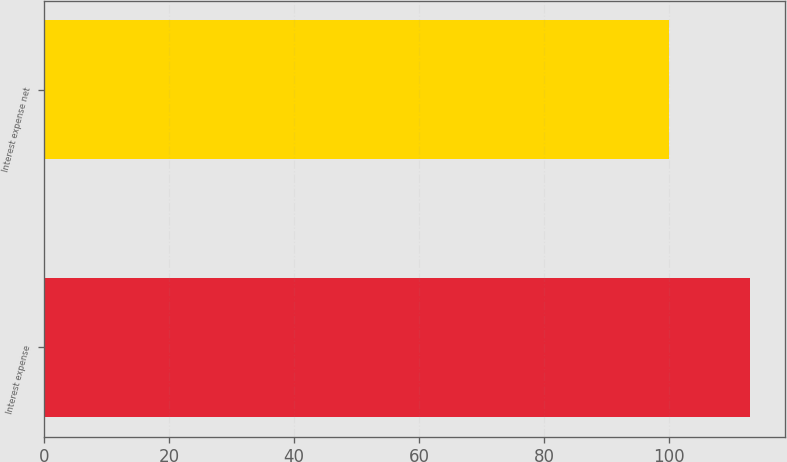<chart> <loc_0><loc_0><loc_500><loc_500><bar_chart><fcel>Interest expense<fcel>Interest expense net<nl><fcel>113<fcel>100<nl></chart> 